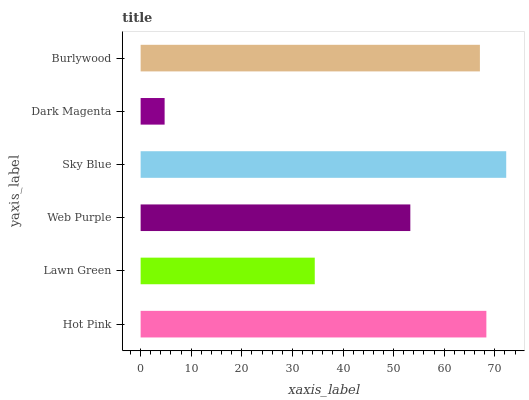Is Dark Magenta the minimum?
Answer yes or no. Yes. Is Sky Blue the maximum?
Answer yes or no. Yes. Is Lawn Green the minimum?
Answer yes or no. No. Is Lawn Green the maximum?
Answer yes or no. No. Is Hot Pink greater than Lawn Green?
Answer yes or no. Yes. Is Lawn Green less than Hot Pink?
Answer yes or no. Yes. Is Lawn Green greater than Hot Pink?
Answer yes or no. No. Is Hot Pink less than Lawn Green?
Answer yes or no. No. Is Burlywood the high median?
Answer yes or no. Yes. Is Web Purple the low median?
Answer yes or no. Yes. Is Web Purple the high median?
Answer yes or no. No. Is Dark Magenta the low median?
Answer yes or no. No. 